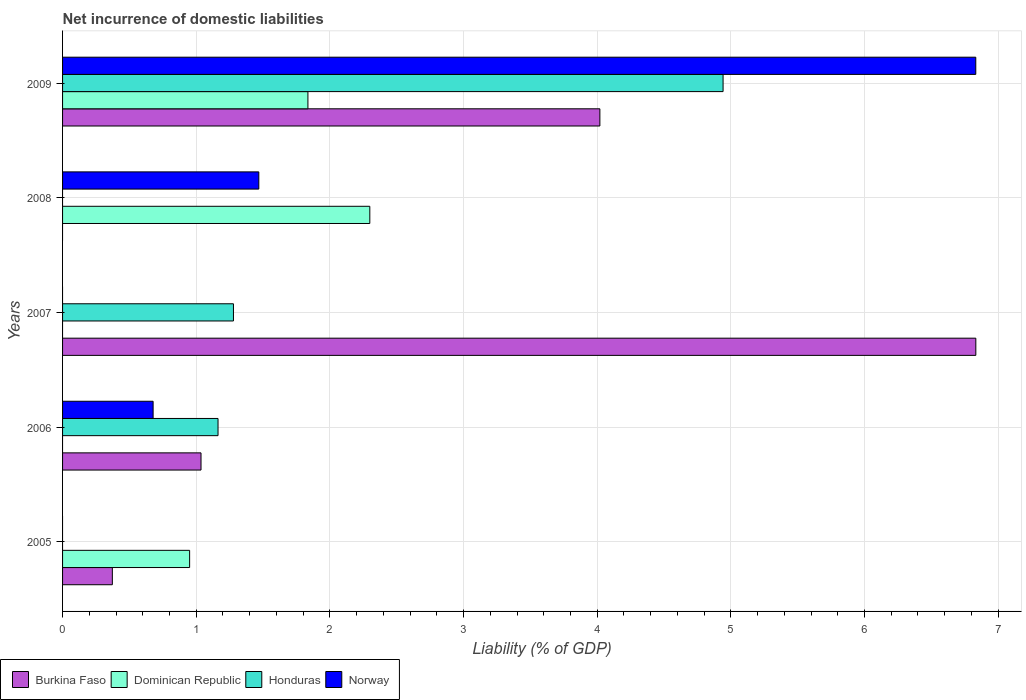How many different coloured bars are there?
Make the answer very short. 4. Are the number of bars on each tick of the Y-axis equal?
Provide a succinct answer. No. In how many cases, is the number of bars for a given year not equal to the number of legend labels?
Keep it short and to the point. 4. Across all years, what is the maximum net incurrence of domestic liabilities in Norway?
Ensure brevity in your answer.  6.83. Across all years, what is the minimum net incurrence of domestic liabilities in Dominican Republic?
Provide a succinct answer. 0. What is the total net incurrence of domestic liabilities in Honduras in the graph?
Keep it short and to the point. 7.38. What is the difference between the net incurrence of domestic liabilities in Norway in 2006 and that in 2009?
Offer a very short reply. -6.16. What is the difference between the net incurrence of domestic liabilities in Burkina Faso in 2009 and the net incurrence of domestic liabilities in Dominican Republic in 2008?
Provide a short and direct response. 1.72. What is the average net incurrence of domestic liabilities in Dominican Republic per year?
Your answer should be compact. 1.02. In the year 2006, what is the difference between the net incurrence of domestic liabilities in Honduras and net incurrence of domestic liabilities in Burkina Faso?
Offer a very short reply. 0.13. What is the ratio of the net incurrence of domestic liabilities in Dominican Republic in 2005 to that in 2008?
Ensure brevity in your answer.  0.41. Is the net incurrence of domestic liabilities in Dominican Republic in 2005 less than that in 2009?
Provide a short and direct response. Yes. What is the difference between the highest and the second highest net incurrence of domestic liabilities in Norway?
Offer a very short reply. 5.36. What is the difference between the highest and the lowest net incurrence of domestic liabilities in Honduras?
Give a very brief answer. 4.94. In how many years, is the net incurrence of domestic liabilities in Dominican Republic greater than the average net incurrence of domestic liabilities in Dominican Republic taken over all years?
Ensure brevity in your answer.  2. Is the sum of the net incurrence of domestic liabilities in Norway in 2006 and 2009 greater than the maximum net incurrence of domestic liabilities in Honduras across all years?
Offer a terse response. Yes. Is it the case that in every year, the sum of the net incurrence of domestic liabilities in Norway and net incurrence of domestic liabilities in Dominican Republic is greater than the sum of net incurrence of domestic liabilities in Burkina Faso and net incurrence of domestic liabilities in Honduras?
Offer a very short reply. No. How many bars are there?
Keep it short and to the point. 13. Are all the bars in the graph horizontal?
Provide a succinct answer. Yes. Are the values on the major ticks of X-axis written in scientific E-notation?
Your response must be concise. No. Does the graph contain any zero values?
Provide a succinct answer. Yes. Where does the legend appear in the graph?
Your answer should be very brief. Bottom left. What is the title of the graph?
Your answer should be very brief. Net incurrence of domestic liabilities. What is the label or title of the X-axis?
Make the answer very short. Liability (% of GDP). What is the Liability (% of GDP) in Burkina Faso in 2005?
Ensure brevity in your answer.  0.37. What is the Liability (% of GDP) in Dominican Republic in 2005?
Your answer should be very brief. 0.95. What is the Liability (% of GDP) of Honduras in 2005?
Provide a succinct answer. 0. What is the Liability (% of GDP) in Burkina Faso in 2006?
Ensure brevity in your answer.  1.04. What is the Liability (% of GDP) in Dominican Republic in 2006?
Your response must be concise. 0. What is the Liability (% of GDP) in Honduras in 2006?
Your response must be concise. 1.16. What is the Liability (% of GDP) of Norway in 2006?
Your response must be concise. 0.68. What is the Liability (% of GDP) in Burkina Faso in 2007?
Offer a terse response. 6.83. What is the Liability (% of GDP) of Honduras in 2007?
Keep it short and to the point. 1.28. What is the Liability (% of GDP) of Norway in 2007?
Ensure brevity in your answer.  0. What is the Liability (% of GDP) in Dominican Republic in 2008?
Keep it short and to the point. 2.3. What is the Liability (% of GDP) in Norway in 2008?
Keep it short and to the point. 1.47. What is the Liability (% of GDP) in Burkina Faso in 2009?
Give a very brief answer. 4.02. What is the Liability (% of GDP) of Dominican Republic in 2009?
Give a very brief answer. 1.84. What is the Liability (% of GDP) of Honduras in 2009?
Ensure brevity in your answer.  4.94. What is the Liability (% of GDP) of Norway in 2009?
Your answer should be very brief. 6.83. Across all years, what is the maximum Liability (% of GDP) in Burkina Faso?
Your response must be concise. 6.83. Across all years, what is the maximum Liability (% of GDP) in Dominican Republic?
Keep it short and to the point. 2.3. Across all years, what is the maximum Liability (% of GDP) of Honduras?
Provide a short and direct response. 4.94. Across all years, what is the maximum Liability (% of GDP) in Norway?
Provide a succinct answer. 6.83. Across all years, what is the minimum Liability (% of GDP) of Burkina Faso?
Give a very brief answer. 0. Across all years, what is the minimum Liability (% of GDP) of Honduras?
Ensure brevity in your answer.  0. Across all years, what is the minimum Liability (% of GDP) in Norway?
Provide a succinct answer. 0. What is the total Liability (% of GDP) in Burkina Faso in the graph?
Ensure brevity in your answer.  12.26. What is the total Liability (% of GDP) of Dominican Republic in the graph?
Your answer should be very brief. 5.08. What is the total Liability (% of GDP) of Honduras in the graph?
Offer a very short reply. 7.38. What is the total Liability (% of GDP) of Norway in the graph?
Offer a terse response. 8.98. What is the difference between the Liability (% of GDP) in Burkina Faso in 2005 and that in 2006?
Offer a very short reply. -0.66. What is the difference between the Liability (% of GDP) in Burkina Faso in 2005 and that in 2007?
Offer a very short reply. -6.46. What is the difference between the Liability (% of GDP) of Dominican Republic in 2005 and that in 2008?
Give a very brief answer. -1.35. What is the difference between the Liability (% of GDP) in Burkina Faso in 2005 and that in 2009?
Provide a succinct answer. -3.65. What is the difference between the Liability (% of GDP) in Dominican Republic in 2005 and that in 2009?
Offer a terse response. -0.89. What is the difference between the Liability (% of GDP) of Burkina Faso in 2006 and that in 2007?
Make the answer very short. -5.8. What is the difference between the Liability (% of GDP) in Honduras in 2006 and that in 2007?
Offer a very short reply. -0.12. What is the difference between the Liability (% of GDP) of Norway in 2006 and that in 2008?
Provide a succinct answer. -0.79. What is the difference between the Liability (% of GDP) in Burkina Faso in 2006 and that in 2009?
Ensure brevity in your answer.  -2.98. What is the difference between the Liability (% of GDP) of Honduras in 2006 and that in 2009?
Give a very brief answer. -3.78. What is the difference between the Liability (% of GDP) of Norway in 2006 and that in 2009?
Make the answer very short. -6.16. What is the difference between the Liability (% of GDP) of Burkina Faso in 2007 and that in 2009?
Offer a very short reply. 2.81. What is the difference between the Liability (% of GDP) of Honduras in 2007 and that in 2009?
Offer a very short reply. -3.66. What is the difference between the Liability (% of GDP) in Dominican Republic in 2008 and that in 2009?
Offer a very short reply. 0.46. What is the difference between the Liability (% of GDP) of Norway in 2008 and that in 2009?
Keep it short and to the point. -5.36. What is the difference between the Liability (% of GDP) of Burkina Faso in 2005 and the Liability (% of GDP) of Honduras in 2006?
Make the answer very short. -0.79. What is the difference between the Liability (% of GDP) of Burkina Faso in 2005 and the Liability (% of GDP) of Norway in 2006?
Your answer should be very brief. -0.3. What is the difference between the Liability (% of GDP) of Dominican Republic in 2005 and the Liability (% of GDP) of Honduras in 2006?
Make the answer very short. -0.21. What is the difference between the Liability (% of GDP) in Dominican Republic in 2005 and the Liability (% of GDP) in Norway in 2006?
Ensure brevity in your answer.  0.27. What is the difference between the Liability (% of GDP) in Burkina Faso in 2005 and the Liability (% of GDP) in Honduras in 2007?
Ensure brevity in your answer.  -0.91. What is the difference between the Liability (% of GDP) of Dominican Republic in 2005 and the Liability (% of GDP) of Honduras in 2007?
Ensure brevity in your answer.  -0.33. What is the difference between the Liability (% of GDP) in Burkina Faso in 2005 and the Liability (% of GDP) in Dominican Republic in 2008?
Ensure brevity in your answer.  -1.93. What is the difference between the Liability (% of GDP) in Burkina Faso in 2005 and the Liability (% of GDP) in Norway in 2008?
Offer a very short reply. -1.1. What is the difference between the Liability (% of GDP) of Dominican Republic in 2005 and the Liability (% of GDP) of Norway in 2008?
Offer a very short reply. -0.52. What is the difference between the Liability (% of GDP) in Burkina Faso in 2005 and the Liability (% of GDP) in Dominican Republic in 2009?
Your response must be concise. -1.46. What is the difference between the Liability (% of GDP) of Burkina Faso in 2005 and the Liability (% of GDP) of Honduras in 2009?
Your answer should be compact. -4.57. What is the difference between the Liability (% of GDP) in Burkina Faso in 2005 and the Liability (% of GDP) in Norway in 2009?
Provide a succinct answer. -6.46. What is the difference between the Liability (% of GDP) of Dominican Republic in 2005 and the Liability (% of GDP) of Honduras in 2009?
Your answer should be very brief. -3.99. What is the difference between the Liability (% of GDP) of Dominican Republic in 2005 and the Liability (% of GDP) of Norway in 2009?
Ensure brevity in your answer.  -5.88. What is the difference between the Liability (% of GDP) of Burkina Faso in 2006 and the Liability (% of GDP) of Honduras in 2007?
Your response must be concise. -0.24. What is the difference between the Liability (% of GDP) of Burkina Faso in 2006 and the Liability (% of GDP) of Dominican Republic in 2008?
Make the answer very short. -1.26. What is the difference between the Liability (% of GDP) in Burkina Faso in 2006 and the Liability (% of GDP) in Norway in 2008?
Ensure brevity in your answer.  -0.43. What is the difference between the Liability (% of GDP) in Honduras in 2006 and the Liability (% of GDP) in Norway in 2008?
Provide a short and direct response. -0.31. What is the difference between the Liability (% of GDP) in Burkina Faso in 2006 and the Liability (% of GDP) in Dominican Republic in 2009?
Offer a very short reply. -0.8. What is the difference between the Liability (% of GDP) in Burkina Faso in 2006 and the Liability (% of GDP) in Honduras in 2009?
Provide a short and direct response. -3.91. What is the difference between the Liability (% of GDP) of Burkina Faso in 2006 and the Liability (% of GDP) of Norway in 2009?
Your response must be concise. -5.8. What is the difference between the Liability (% of GDP) in Honduras in 2006 and the Liability (% of GDP) in Norway in 2009?
Offer a terse response. -5.67. What is the difference between the Liability (% of GDP) of Burkina Faso in 2007 and the Liability (% of GDP) of Dominican Republic in 2008?
Provide a short and direct response. 4.53. What is the difference between the Liability (% of GDP) in Burkina Faso in 2007 and the Liability (% of GDP) in Norway in 2008?
Keep it short and to the point. 5.36. What is the difference between the Liability (% of GDP) of Honduras in 2007 and the Liability (% of GDP) of Norway in 2008?
Your response must be concise. -0.19. What is the difference between the Liability (% of GDP) in Burkina Faso in 2007 and the Liability (% of GDP) in Dominican Republic in 2009?
Keep it short and to the point. 5. What is the difference between the Liability (% of GDP) of Burkina Faso in 2007 and the Liability (% of GDP) of Honduras in 2009?
Your answer should be very brief. 1.89. What is the difference between the Liability (% of GDP) of Honduras in 2007 and the Liability (% of GDP) of Norway in 2009?
Provide a short and direct response. -5.55. What is the difference between the Liability (% of GDP) of Dominican Republic in 2008 and the Liability (% of GDP) of Honduras in 2009?
Your answer should be very brief. -2.64. What is the difference between the Liability (% of GDP) in Dominican Republic in 2008 and the Liability (% of GDP) in Norway in 2009?
Give a very brief answer. -4.53. What is the average Liability (% of GDP) of Burkina Faso per year?
Offer a very short reply. 2.45. What is the average Liability (% of GDP) in Honduras per year?
Provide a short and direct response. 1.48. What is the average Liability (% of GDP) of Norway per year?
Your answer should be very brief. 1.8. In the year 2005, what is the difference between the Liability (% of GDP) of Burkina Faso and Liability (% of GDP) of Dominican Republic?
Ensure brevity in your answer.  -0.58. In the year 2006, what is the difference between the Liability (% of GDP) in Burkina Faso and Liability (% of GDP) in Honduras?
Your response must be concise. -0.13. In the year 2006, what is the difference between the Liability (% of GDP) in Burkina Faso and Liability (% of GDP) in Norway?
Make the answer very short. 0.36. In the year 2006, what is the difference between the Liability (% of GDP) in Honduras and Liability (% of GDP) in Norway?
Offer a very short reply. 0.49. In the year 2007, what is the difference between the Liability (% of GDP) in Burkina Faso and Liability (% of GDP) in Honduras?
Provide a short and direct response. 5.55. In the year 2008, what is the difference between the Liability (% of GDP) in Dominican Republic and Liability (% of GDP) in Norway?
Your response must be concise. 0.83. In the year 2009, what is the difference between the Liability (% of GDP) in Burkina Faso and Liability (% of GDP) in Dominican Republic?
Your answer should be very brief. 2.18. In the year 2009, what is the difference between the Liability (% of GDP) in Burkina Faso and Liability (% of GDP) in Honduras?
Provide a short and direct response. -0.92. In the year 2009, what is the difference between the Liability (% of GDP) of Burkina Faso and Liability (% of GDP) of Norway?
Offer a very short reply. -2.81. In the year 2009, what is the difference between the Liability (% of GDP) of Dominican Republic and Liability (% of GDP) of Honduras?
Keep it short and to the point. -3.11. In the year 2009, what is the difference between the Liability (% of GDP) in Dominican Republic and Liability (% of GDP) in Norway?
Provide a short and direct response. -5. In the year 2009, what is the difference between the Liability (% of GDP) in Honduras and Liability (% of GDP) in Norway?
Your answer should be compact. -1.89. What is the ratio of the Liability (% of GDP) in Burkina Faso in 2005 to that in 2006?
Make the answer very short. 0.36. What is the ratio of the Liability (% of GDP) in Burkina Faso in 2005 to that in 2007?
Your response must be concise. 0.05. What is the ratio of the Liability (% of GDP) of Dominican Republic in 2005 to that in 2008?
Offer a very short reply. 0.41. What is the ratio of the Liability (% of GDP) in Burkina Faso in 2005 to that in 2009?
Your response must be concise. 0.09. What is the ratio of the Liability (% of GDP) in Dominican Republic in 2005 to that in 2009?
Give a very brief answer. 0.52. What is the ratio of the Liability (% of GDP) of Burkina Faso in 2006 to that in 2007?
Your answer should be very brief. 0.15. What is the ratio of the Liability (% of GDP) of Honduras in 2006 to that in 2007?
Offer a terse response. 0.91. What is the ratio of the Liability (% of GDP) in Norway in 2006 to that in 2008?
Ensure brevity in your answer.  0.46. What is the ratio of the Liability (% of GDP) of Burkina Faso in 2006 to that in 2009?
Offer a very short reply. 0.26. What is the ratio of the Liability (% of GDP) of Honduras in 2006 to that in 2009?
Your response must be concise. 0.24. What is the ratio of the Liability (% of GDP) of Norway in 2006 to that in 2009?
Offer a terse response. 0.1. What is the ratio of the Liability (% of GDP) of Burkina Faso in 2007 to that in 2009?
Provide a short and direct response. 1.7. What is the ratio of the Liability (% of GDP) of Honduras in 2007 to that in 2009?
Provide a succinct answer. 0.26. What is the ratio of the Liability (% of GDP) of Dominican Republic in 2008 to that in 2009?
Offer a very short reply. 1.25. What is the ratio of the Liability (% of GDP) of Norway in 2008 to that in 2009?
Provide a succinct answer. 0.21. What is the difference between the highest and the second highest Liability (% of GDP) in Burkina Faso?
Your answer should be compact. 2.81. What is the difference between the highest and the second highest Liability (% of GDP) of Dominican Republic?
Keep it short and to the point. 0.46. What is the difference between the highest and the second highest Liability (% of GDP) of Honduras?
Offer a terse response. 3.66. What is the difference between the highest and the second highest Liability (% of GDP) in Norway?
Ensure brevity in your answer.  5.36. What is the difference between the highest and the lowest Liability (% of GDP) in Burkina Faso?
Keep it short and to the point. 6.83. What is the difference between the highest and the lowest Liability (% of GDP) in Dominican Republic?
Provide a succinct answer. 2.3. What is the difference between the highest and the lowest Liability (% of GDP) of Honduras?
Provide a succinct answer. 4.94. What is the difference between the highest and the lowest Liability (% of GDP) of Norway?
Provide a short and direct response. 6.83. 